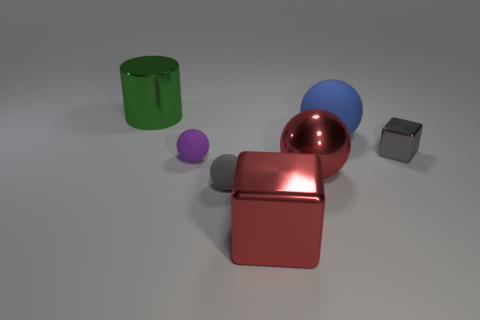Subtract 1 spheres. How many spheres are left? 3 Subtract all cyan cylinders. Subtract all purple blocks. How many cylinders are left? 1 Add 3 big metal balls. How many objects exist? 10 Subtract all cubes. How many objects are left? 5 Subtract all big red shiny blocks. Subtract all purple things. How many objects are left? 5 Add 6 small gray cubes. How many small gray cubes are left? 7 Add 7 small cyan rubber cylinders. How many small cyan rubber cylinders exist? 7 Subtract 0 yellow blocks. How many objects are left? 7 